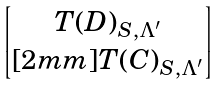<formula> <loc_0><loc_0><loc_500><loc_500>\begin{bmatrix} T ( D ) _ { S , \Lambda ^ { \prime } } \\ [ 2 m m ] T ( C ) _ { S , \Lambda ^ { \prime } } \end{bmatrix}</formula> 